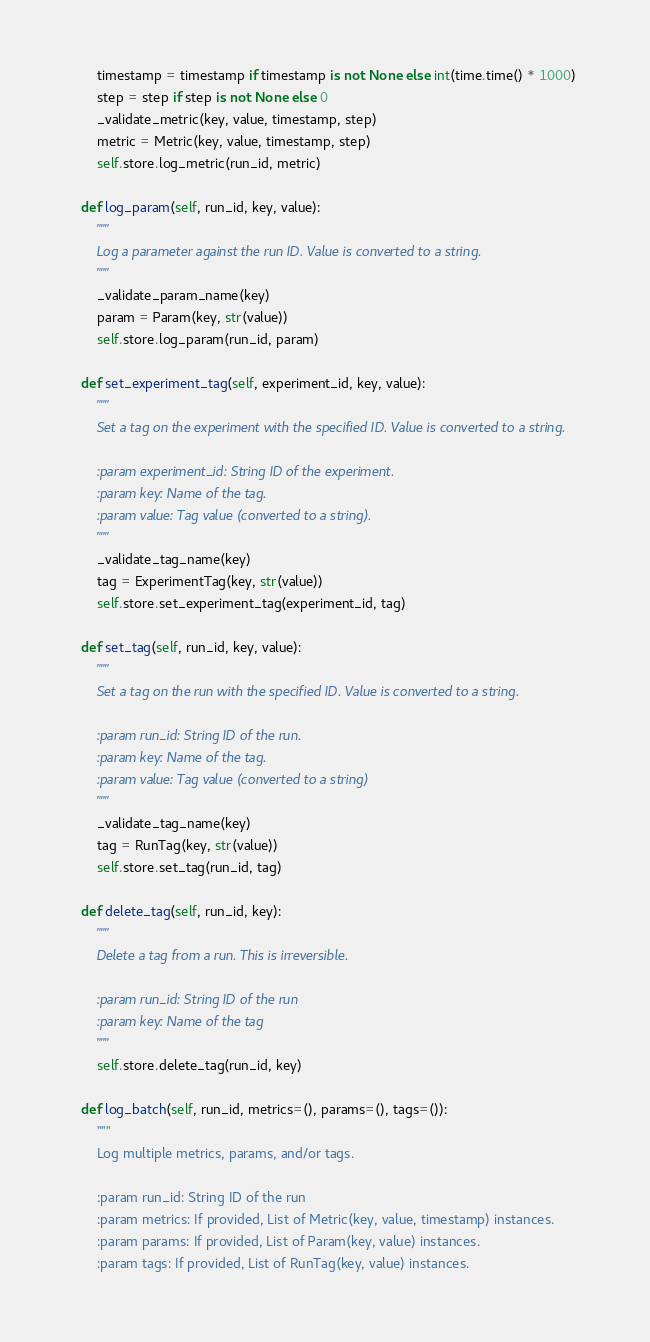Convert code to text. <code><loc_0><loc_0><loc_500><loc_500><_Python_>        timestamp = timestamp if timestamp is not None else int(time.time() * 1000)
        step = step if step is not None else 0
        _validate_metric(key, value, timestamp, step)
        metric = Metric(key, value, timestamp, step)
        self.store.log_metric(run_id, metric)

    def log_param(self, run_id, key, value):
        """
        Log a parameter against the run ID. Value is converted to a string.
        """
        _validate_param_name(key)
        param = Param(key, str(value))
        self.store.log_param(run_id, param)

    def set_experiment_tag(self, experiment_id, key, value):
        """
        Set a tag on the experiment with the specified ID. Value is converted to a string.

        :param experiment_id: String ID of the experiment.
        :param key: Name of the tag.
        :param value: Tag value (converted to a string).
        """
        _validate_tag_name(key)
        tag = ExperimentTag(key, str(value))
        self.store.set_experiment_tag(experiment_id, tag)

    def set_tag(self, run_id, key, value):
        """
        Set a tag on the run with the specified ID. Value is converted to a string.

        :param run_id: String ID of the run.
        :param key: Name of the tag.
        :param value: Tag value (converted to a string)
        """
        _validate_tag_name(key)
        tag = RunTag(key, str(value))
        self.store.set_tag(run_id, tag)

    def delete_tag(self, run_id, key):
        """
        Delete a tag from a run. This is irreversible.

        :param run_id: String ID of the run
        :param key: Name of the tag
        """
        self.store.delete_tag(run_id, key)

    def log_batch(self, run_id, metrics=(), params=(), tags=()):
        """
        Log multiple metrics, params, and/or tags.

        :param run_id: String ID of the run
        :param metrics: If provided, List of Metric(key, value, timestamp) instances.
        :param params: If provided, List of Param(key, value) instances.
        :param tags: If provided, List of RunTag(key, value) instances.
</code> 